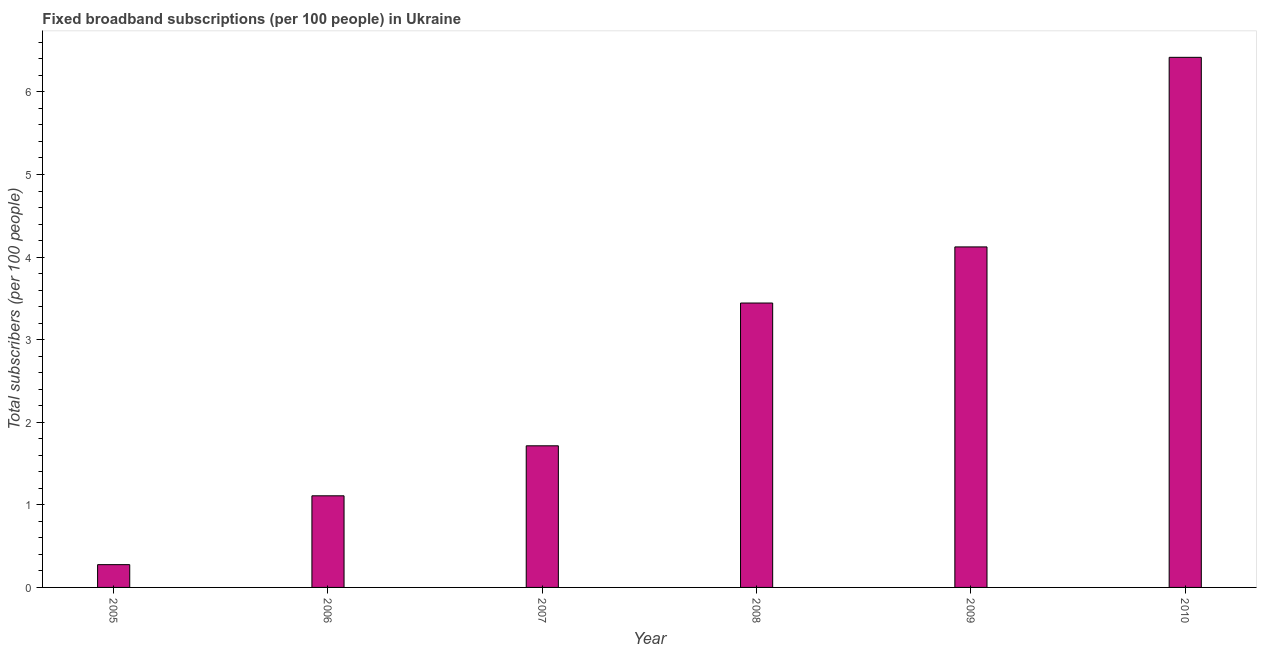Does the graph contain any zero values?
Ensure brevity in your answer.  No. Does the graph contain grids?
Provide a short and direct response. No. What is the title of the graph?
Provide a succinct answer. Fixed broadband subscriptions (per 100 people) in Ukraine. What is the label or title of the X-axis?
Provide a succinct answer. Year. What is the label or title of the Y-axis?
Your response must be concise. Total subscribers (per 100 people). What is the total number of fixed broadband subscriptions in 2010?
Give a very brief answer. 6.42. Across all years, what is the maximum total number of fixed broadband subscriptions?
Give a very brief answer. 6.42. Across all years, what is the minimum total number of fixed broadband subscriptions?
Provide a short and direct response. 0.28. In which year was the total number of fixed broadband subscriptions maximum?
Provide a succinct answer. 2010. In which year was the total number of fixed broadband subscriptions minimum?
Your answer should be very brief. 2005. What is the sum of the total number of fixed broadband subscriptions?
Provide a succinct answer. 17.09. What is the difference between the total number of fixed broadband subscriptions in 2007 and 2009?
Provide a short and direct response. -2.41. What is the average total number of fixed broadband subscriptions per year?
Provide a succinct answer. 2.85. What is the median total number of fixed broadband subscriptions?
Your response must be concise. 2.58. Do a majority of the years between 2006 and 2007 (inclusive) have total number of fixed broadband subscriptions greater than 2.4 ?
Give a very brief answer. No. What is the ratio of the total number of fixed broadband subscriptions in 2008 to that in 2010?
Make the answer very short. 0.54. Is the total number of fixed broadband subscriptions in 2005 less than that in 2008?
Your answer should be compact. Yes. Is the difference between the total number of fixed broadband subscriptions in 2007 and 2010 greater than the difference between any two years?
Ensure brevity in your answer.  No. What is the difference between the highest and the second highest total number of fixed broadband subscriptions?
Offer a terse response. 2.3. What is the difference between the highest and the lowest total number of fixed broadband subscriptions?
Offer a terse response. 6.14. What is the Total subscribers (per 100 people) of 2005?
Your response must be concise. 0.28. What is the Total subscribers (per 100 people) in 2006?
Your response must be concise. 1.11. What is the Total subscribers (per 100 people) in 2007?
Provide a succinct answer. 1.71. What is the Total subscribers (per 100 people) of 2008?
Keep it short and to the point. 3.44. What is the Total subscribers (per 100 people) of 2009?
Give a very brief answer. 4.12. What is the Total subscribers (per 100 people) in 2010?
Make the answer very short. 6.42. What is the difference between the Total subscribers (per 100 people) in 2005 and 2006?
Keep it short and to the point. -0.83. What is the difference between the Total subscribers (per 100 people) in 2005 and 2007?
Offer a very short reply. -1.44. What is the difference between the Total subscribers (per 100 people) in 2005 and 2008?
Your answer should be compact. -3.17. What is the difference between the Total subscribers (per 100 people) in 2005 and 2009?
Give a very brief answer. -3.85. What is the difference between the Total subscribers (per 100 people) in 2005 and 2010?
Keep it short and to the point. -6.14. What is the difference between the Total subscribers (per 100 people) in 2006 and 2007?
Offer a terse response. -0.61. What is the difference between the Total subscribers (per 100 people) in 2006 and 2008?
Give a very brief answer. -2.33. What is the difference between the Total subscribers (per 100 people) in 2006 and 2009?
Give a very brief answer. -3.01. What is the difference between the Total subscribers (per 100 people) in 2006 and 2010?
Keep it short and to the point. -5.31. What is the difference between the Total subscribers (per 100 people) in 2007 and 2008?
Keep it short and to the point. -1.73. What is the difference between the Total subscribers (per 100 people) in 2007 and 2009?
Give a very brief answer. -2.41. What is the difference between the Total subscribers (per 100 people) in 2007 and 2010?
Your response must be concise. -4.7. What is the difference between the Total subscribers (per 100 people) in 2008 and 2009?
Give a very brief answer. -0.68. What is the difference between the Total subscribers (per 100 people) in 2008 and 2010?
Keep it short and to the point. -2.98. What is the difference between the Total subscribers (per 100 people) in 2009 and 2010?
Keep it short and to the point. -2.3. What is the ratio of the Total subscribers (per 100 people) in 2005 to that in 2006?
Give a very brief answer. 0.25. What is the ratio of the Total subscribers (per 100 people) in 2005 to that in 2007?
Keep it short and to the point. 0.16. What is the ratio of the Total subscribers (per 100 people) in 2005 to that in 2008?
Give a very brief answer. 0.08. What is the ratio of the Total subscribers (per 100 people) in 2005 to that in 2009?
Your answer should be very brief. 0.07. What is the ratio of the Total subscribers (per 100 people) in 2005 to that in 2010?
Your response must be concise. 0.04. What is the ratio of the Total subscribers (per 100 people) in 2006 to that in 2007?
Make the answer very short. 0.65. What is the ratio of the Total subscribers (per 100 people) in 2006 to that in 2008?
Provide a short and direct response. 0.32. What is the ratio of the Total subscribers (per 100 people) in 2006 to that in 2009?
Offer a terse response. 0.27. What is the ratio of the Total subscribers (per 100 people) in 2006 to that in 2010?
Give a very brief answer. 0.17. What is the ratio of the Total subscribers (per 100 people) in 2007 to that in 2008?
Offer a very short reply. 0.5. What is the ratio of the Total subscribers (per 100 people) in 2007 to that in 2009?
Your answer should be very brief. 0.42. What is the ratio of the Total subscribers (per 100 people) in 2007 to that in 2010?
Keep it short and to the point. 0.27. What is the ratio of the Total subscribers (per 100 people) in 2008 to that in 2009?
Provide a succinct answer. 0.83. What is the ratio of the Total subscribers (per 100 people) in 2008 to that in 2010?
Offer a terse response. 0.54. What is the ratio of the Total subscribers (per 100 people) in 2009 to that in 2010?
Keep it short and to the point. 0.64. 